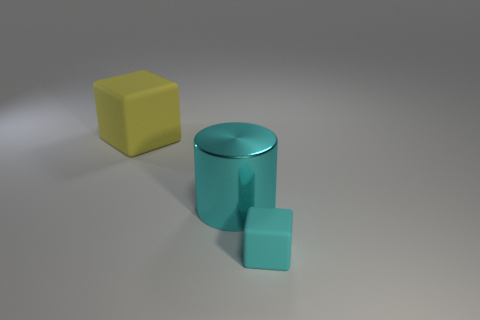Is there a gray shiny cube?
Your response must be concise. No. How many other objects are the same shape as the yellow matte object?
Provide a short and direct response. 1. There is a cylinder that is behind the small matte thing; does it have the same color as the cube that is on the left side of the cyan rubber object?
Make the answer very short. No. There is a block that is left of the rubber block that is right of the large thing left of the cyan cylinder; what size is it?
Ensure brevity in your answer.  Large. Are there an equal number of big shiny things in front of the big cyan object and big metallic things that are on the left side of the big yellow rubber object?
Ensure brevity in your answer.  Yes. Are there any large cyan cubes that have the same material as the large cyan object?
Keep it short and to the point. No. Is the large thing that is in front of the big yellow rubber cube made of the same material as the tiny cyan thing?
Your answer should be compact. No. How big is the object that is both behind the small cyan rubber thing and right of the yellow matte object?
Your response must be concise. Large. What is the color of the large block?
Give a very brief answer. Yellow. How many big yellow cubes are there?
Your response must be concise. 1. 